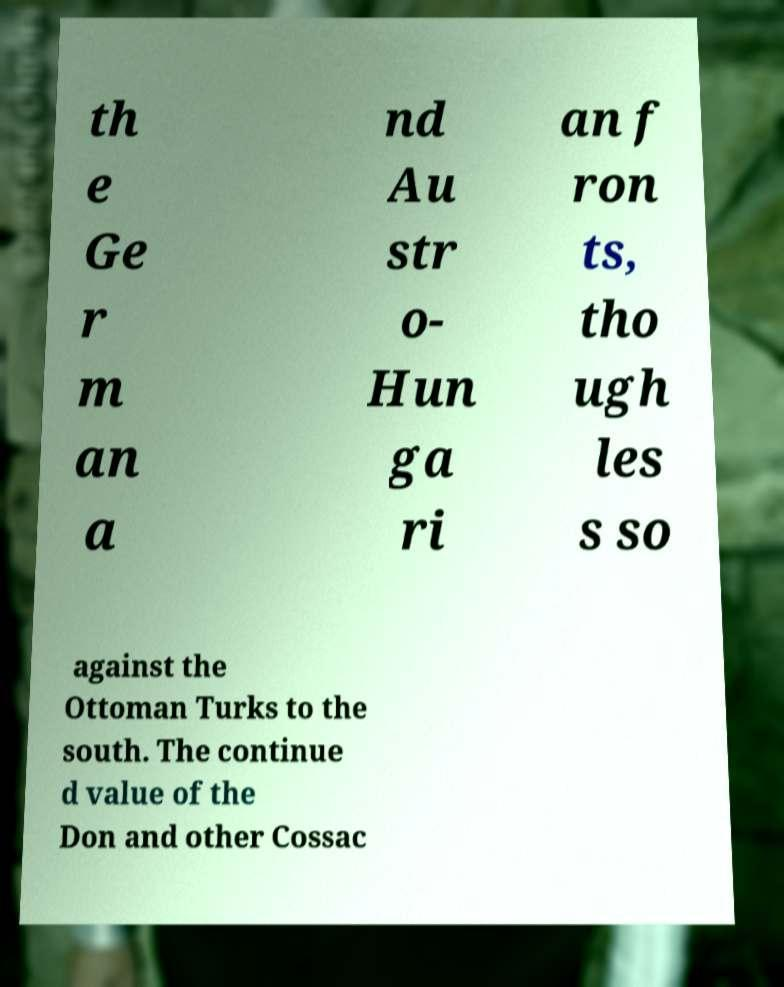Please read and relay the text visible in this image. What does it say? th e Ge r m an a nd Au str o- Hun ga ri an f ron ts, tho ugh les s so against the Ottoman Turks to the south. The continue d value of the Don and other Cossac 